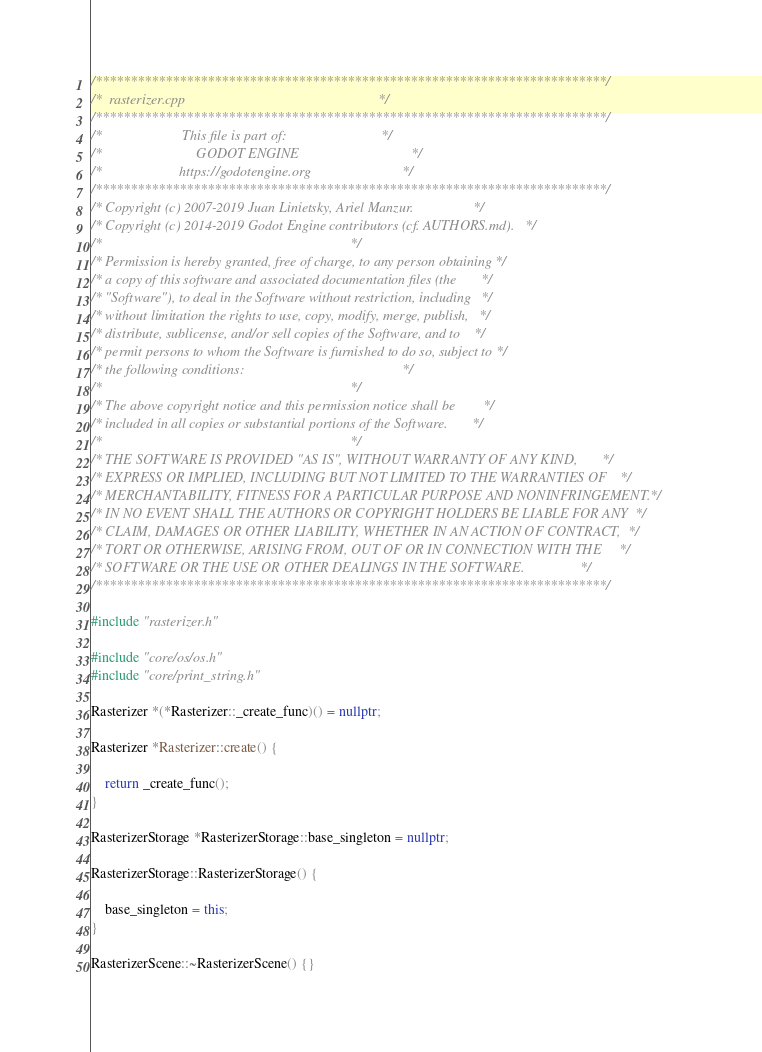<code> <loc_0><loc_0><loc_500><loc_500><_C++_>/*************************************************************************/
/*  rasterizer.cpp                                                       */
/*************************************************************************/
/*                       This file is part of:                           */
/*                           GODOT ENGINE                                */
/*                      https://godotengine.org                          */
/*************************************************************************/
/* Copyright (c) 2007-2019 Juan Linietsky, Ariel Manzur.                 */
/* Copyright (c) 2014-2019 Godot Engine contributors (cf. AUTHORS.md).   */
/*                                                                       */
/* Permission is hereby granted, free of charge, to any person obtaining */
/* a copy of this software and associated documentation files (the       */
/* "Software"), to deal in the Software without restriction, including   */
/* without limitation the rights to use, copy, modify, merge, publish,   */
/* distribute, sublicense, and/or sell copies of the Software, and to    */
/* permit persons to whom the Software is furnished to do so, subject to */
/* the following conditions:                                             */
/*                                                                       */
/* The above copyright notice and this permission notice shall be        */
/* included in all copies or substantial portions of the Software.       */
/*                                                                       */
/* THE SOFTWARE IS PROVIDED "AS IS", WITHOUT WARRANTY OF ANY KIND,       */
/* EXPRESS OR IMPLIED, INCLUDING BUT NOT LIMITED TO THE WARRANTIES OF    */
/* MERCHANTABILITY, FITNESS FOR A PARTICULAR PURPOSE AND NONINFRINGEMENT.*/
/* IN NO EVENT SHALL THE AUTHORS OR COPYRIGHT HOLDERS BE LIABLE FOR ANY  */
/* CLAIM, DAMAGES OR OTHER LIABILITY, WHETHER IN AN ACTION OF CONTRACT,  */
/* TORT OR OTHERWISE, ARISING FROM, OUT OF OR IN CONNECTION WITH THE     */
/* SOFTWARE OR THE USE OR OTHER DEALINGS IN THE SOFTWARE.                */
/*************************************************************************/

#include "rasterizer.h"

#include "core/os/os.h"
#include "core/print_string.h"

Rasterizer *(*Rasterizer::_create_func)() = nullptr;

Rasterizer *Rasterizer::create() {

	return _create_func();
}

RasterizerStorage *RasterizerStorage::base_singleton = nullptr;

RasterizerStorage::RasterizerStorage() {

	base_singleton = this;
}

RasterizerScene::~RasterizerScene() {}
</code> 